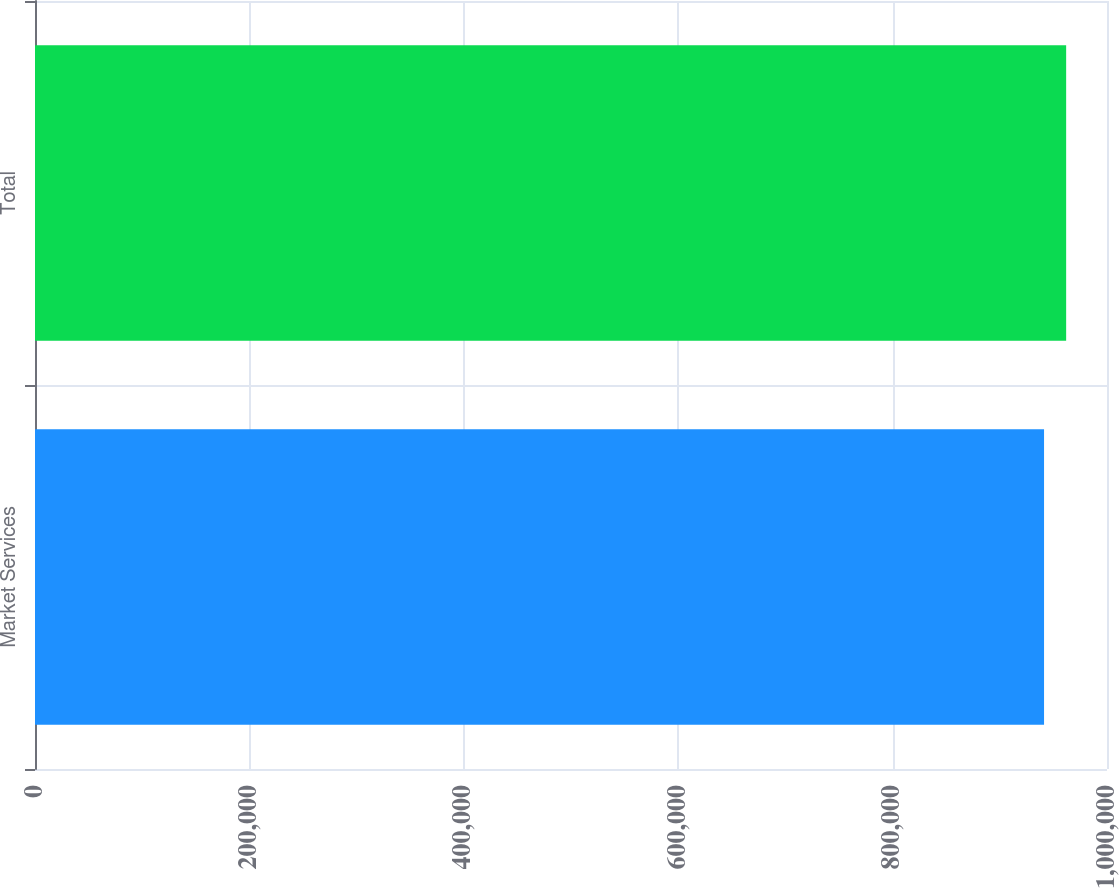Convert chart to OTSL. <chart><loc_0><loc_0><loc_500><loc_500><bar_chart><fcel>Market Services<fcel>Total<nl><fcel>941275<fcel>961893<nl></chart> 